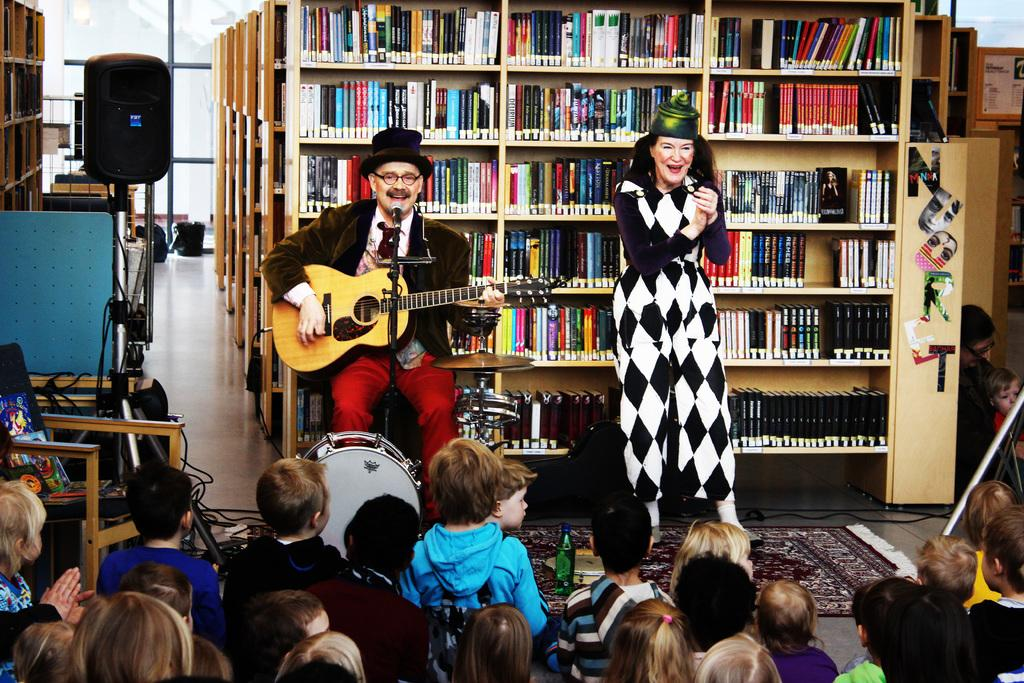What is the person in the image doing? The person is playing a guitar and singing. How is the person's voice being amplified? The person is using a microphone. What is the woman in the image doing? The woman is clapping. Who is the audience for the person playing the guitar? There are multiple children sitting in front of the person playing the guitar. What shape is the meeting table in the image? There is no meeting table present in the image. How does the roll of paper contribute to the performance in the image? There is no roll of paper mentioned in the image; the person is using a microphone for amplification. 